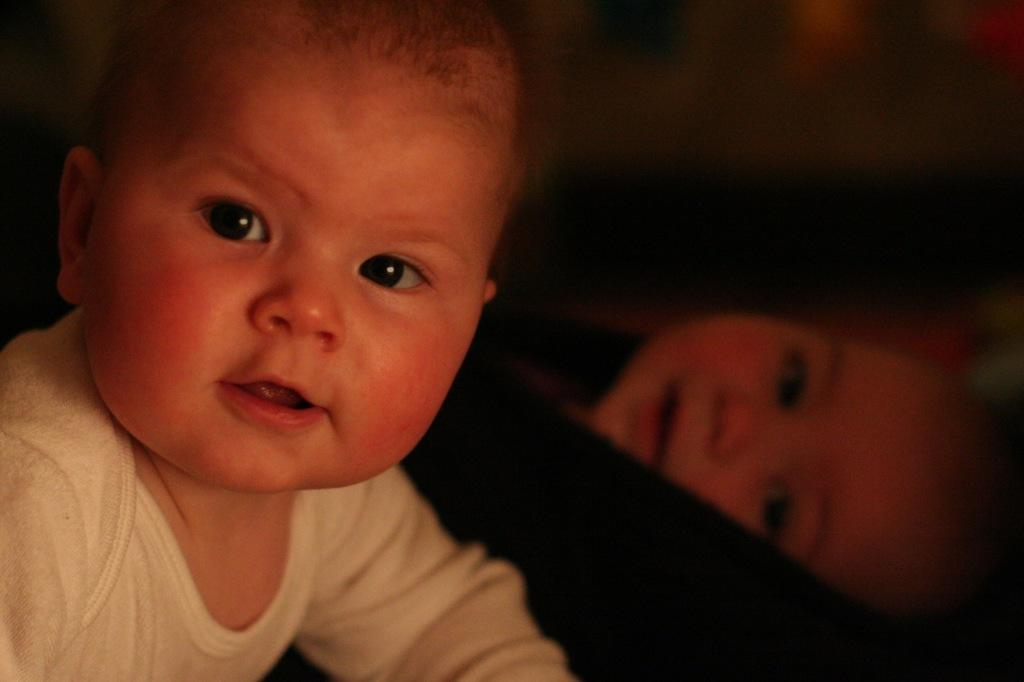Who is present in the image? There are kids in the image. What can be seen in the center of the image? There is a black object in the center of the image. Can you describe the background of the image? The background of the image is blurry. How many men are holding eggs in the image? There are no men or eggs present in the image. 